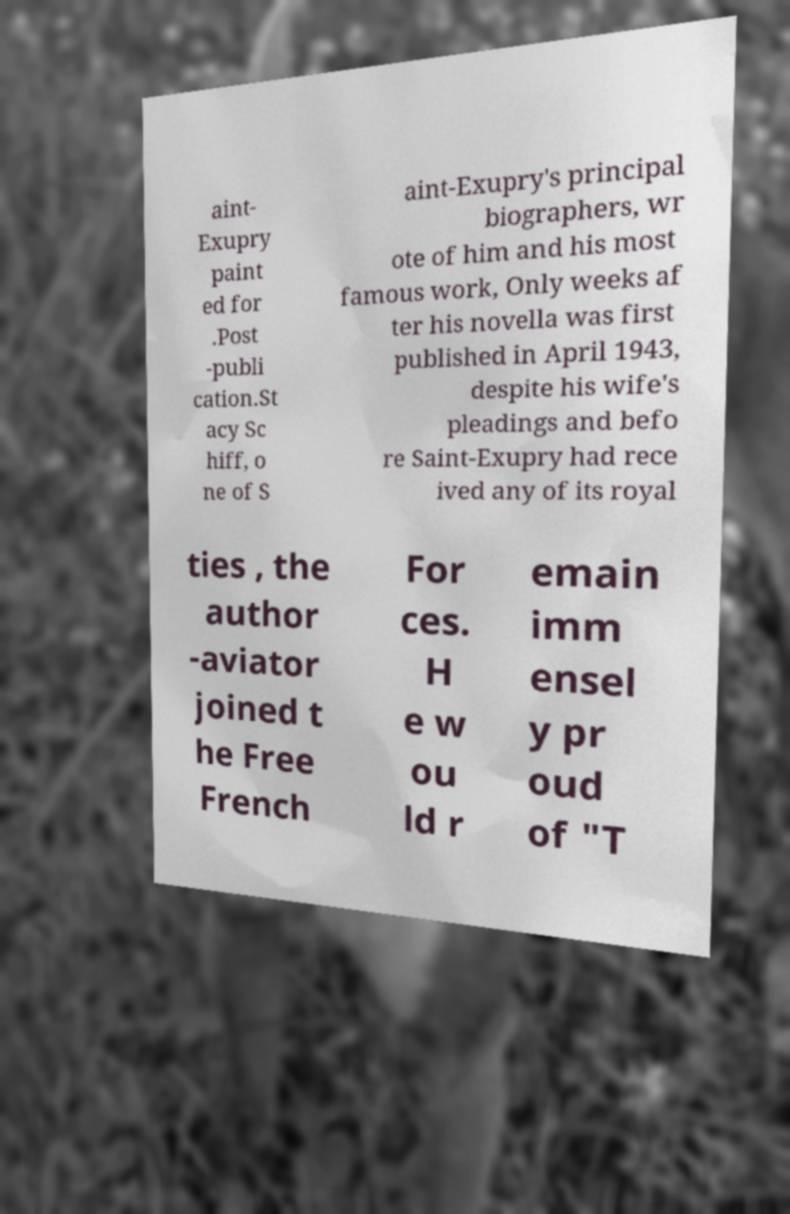Please read and relay the text visible in this image. What does it say? aint- Exupry paint ed for .Post -publi cation.St acy Sc hiff, o ne of S aint-Exupry's principal biographers, wr ote of him and his most famous work, Only weeks af ter his novella was first published in April 1943, despite his wife's pleadings and befo re Saint-Exupry had rece ived any of its royal ties , the author -aviator joined t he Free French For ces. H e w ou ld r emain imm ensel y pr oud of "T 